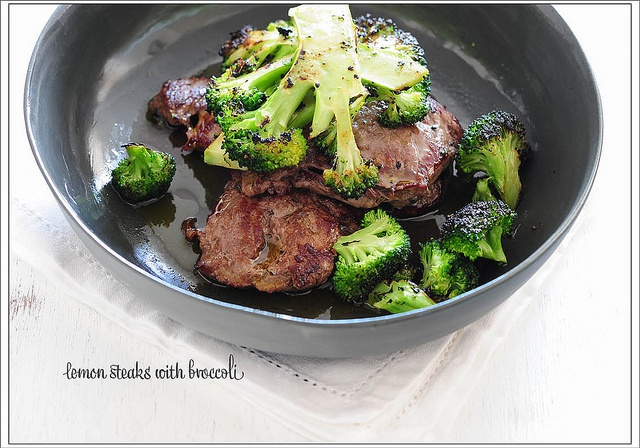Describe the objects in this image and their specific colors. I can see bowl in gray, black, darkgray, and ivory tones, broccoli in gray, ivory, khaki, black, and darkgreen tones, broccoli in gray, black, darkgreen, and green tones, broccoli in gray, black, darkgreen, and olive tones, and broccoli in gray, black, green, and darkgreen tones in this image. 